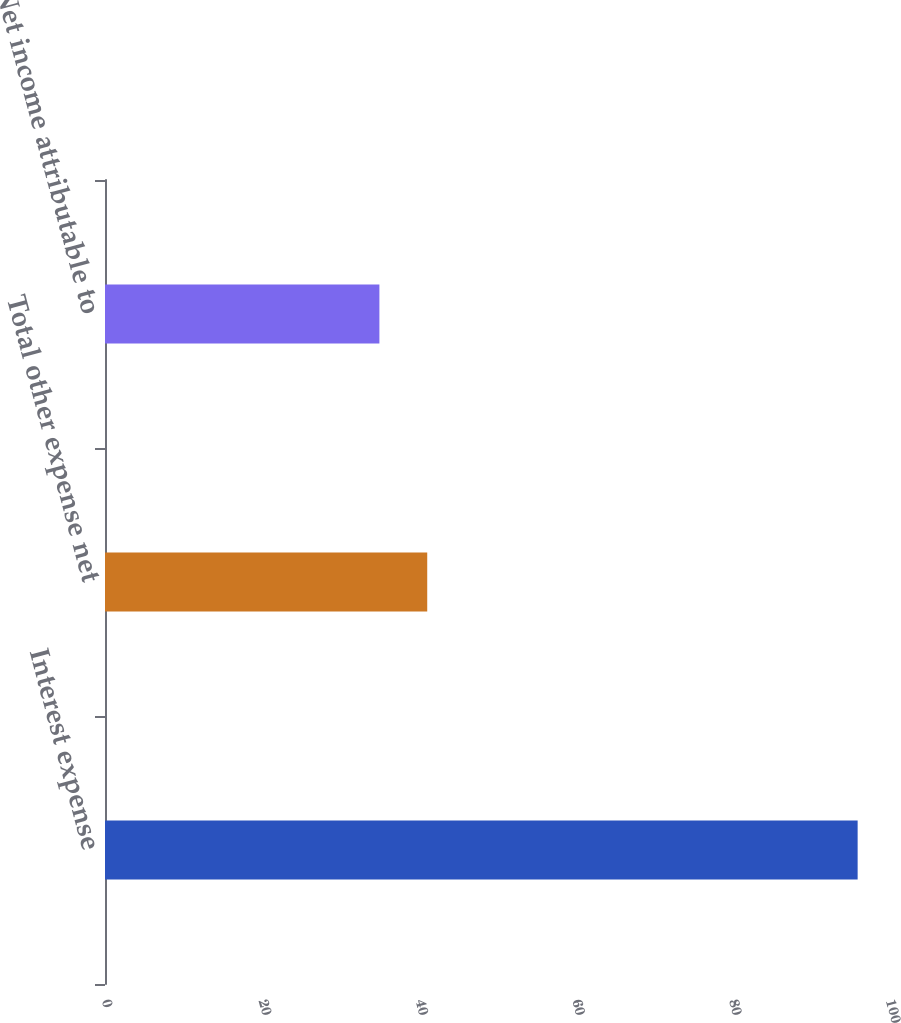<chart> <loc_0><loc_0><loc_500><loc_500><bar_chart><fcel>Interest expense<fcel>Total other expense net<fcel>Net income attributable to<nl><fcel>96<fcel>41.1<fcel>35<nl></chart> 